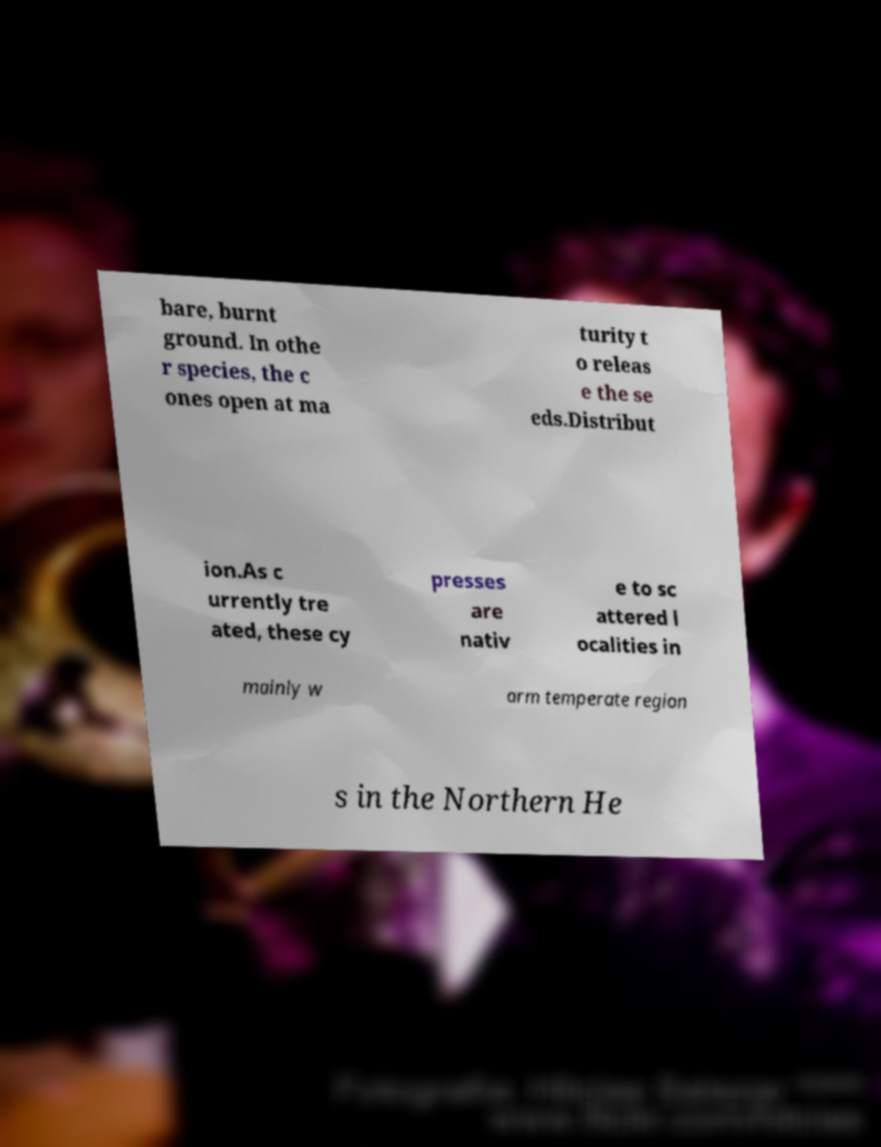Can you accurately transcribe the text from the provided image for me? bare, burnt ground. In othe r species, the c ones open at ma turity t o releas e the se eds.Distribut ion.As c urrently tre ated, these cy presses are nativ e to sc attered l ocalities in mainly w arm temperate region s in the Northern He 